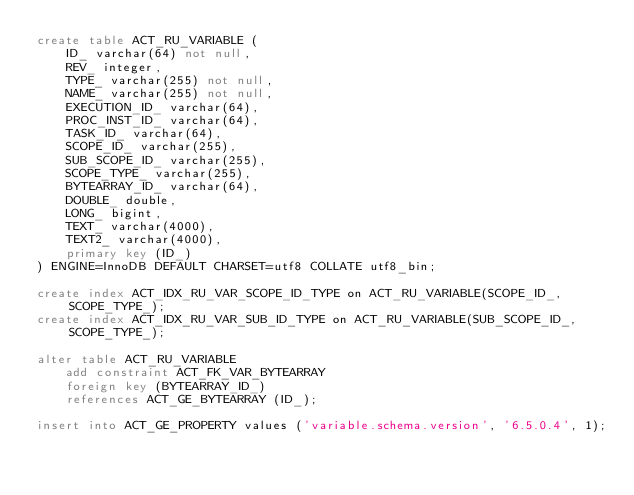Convert code to text. <code><loc_0><loc_0><loc_500><loc_500><_SQL_>create table ACT_RU_VARIABLE (
    ID_ varchar(64) not null,
    REV_ integer,
    TYPE_ varchar(255) not null,
    NAME_ varchar(255) not null,
    EXECUTION_ID_ varchar(64),
    PROC_INST_ID_ varchar(64),
    TASK_ID_ varchar(64),
    SCOPE_ID_ varchar(255),
    SUB_SCOPE_ID_ varchar(255),
    SCOPE_TYPE_ varchar(255),
    BYTEARRAY_ID_ varchar(64),
    DOUBLE_ double,
    LONG_ bigint,
    TEXT_ varchar(4000),
    TEXT2_ varchar(4000),
    primary key (ID_)
) ENGINE=InnoDB DEFAULT CHARSET=utf8 COLLATE utf8_bin;

create index ACT_IDX_RU_VAR_SCOPE_ID_TYPE on ACT_RU_VARIABLE(SCOPE_ID_, SCOPE_TYPE_);
create index ACT_IDX_RU_VAR_SUB_ID_TYPE on ACT_RU_VARIABLE(SUB_SCOPE_ID_, SCOPE_TYPE_);

alter table ACT_RU_VARIABLE 
    add constraint ACT_FK_VAR_BYTEARRAY 
    foreign key (BYTEARRAY_ID_) 
    references ACT_GE_BYTEARRAY (ID_);

insert into ACT_GE_PROPERTY values ('variable.schema.version', '6.5.0.4', 1);</code> 